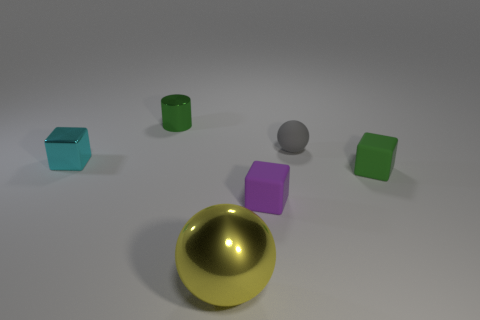What might be the function of these objects in real life? The objects in the image don't seem to serve any practical real-life function as they are presented here; they come across more like primitive shapes one might use in a 3D modeling software for training, design visualization, or graphic art purposes rather than functional items. 